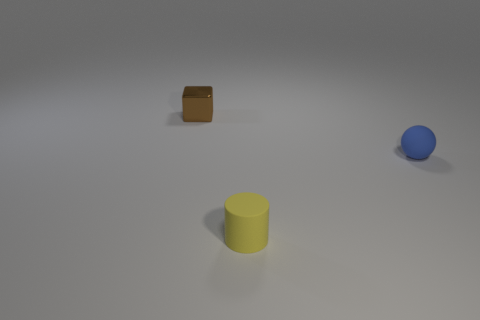Could you estimate the dimensions of the yellow cylinder in relation to the other objects? While it's difficult to provide an exact measurement without scale references, the yellow cylinder appears to be taller than both the brown cube and the blue sphere. If the cube and the sphere are considered to be of similar size, the cylinder might be about one and a half times their height, based solely on visual estimation from this perspective. 